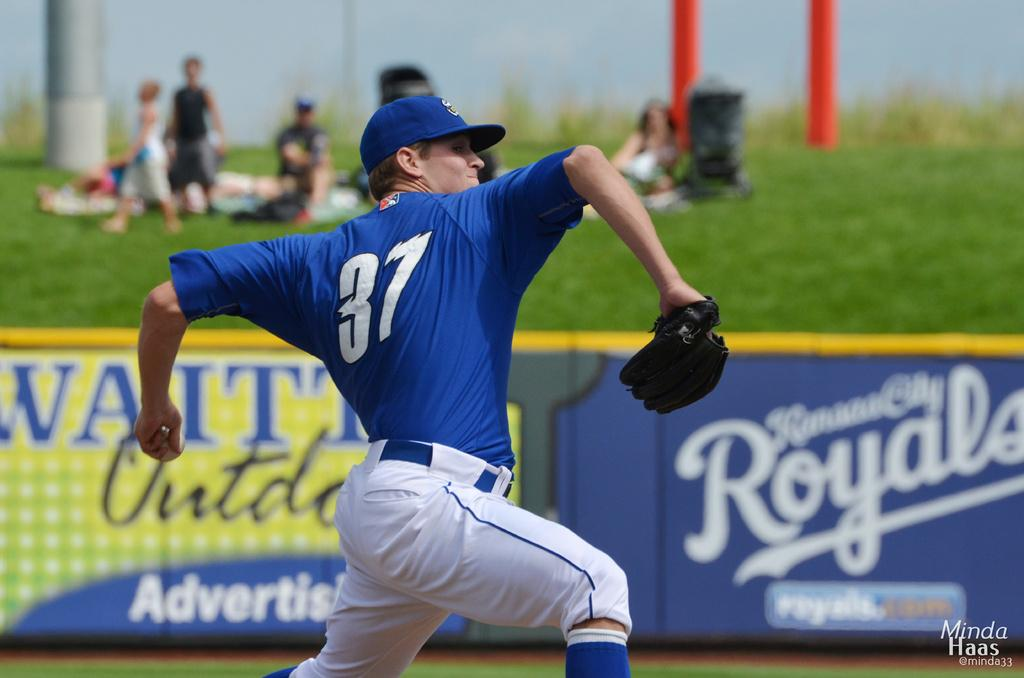Provide a one-sentence caption for the provided image. Baseball pitcher on the mound with a Royals sign in the background. 